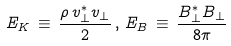Convert formula to latex. <formula><loc_0><loc_0><loc_500><loc_500>E _ { K } \, \equiv \, \frac { \rho \, v _ { \perp } ^ { \ast } v _ { \perp } } { 2 } \, , \, E _ { B } \, \equiv \, \frac { B _ { \perp } ^ { \ast } B _ { \perp } } { 8 \pi }</formula> 